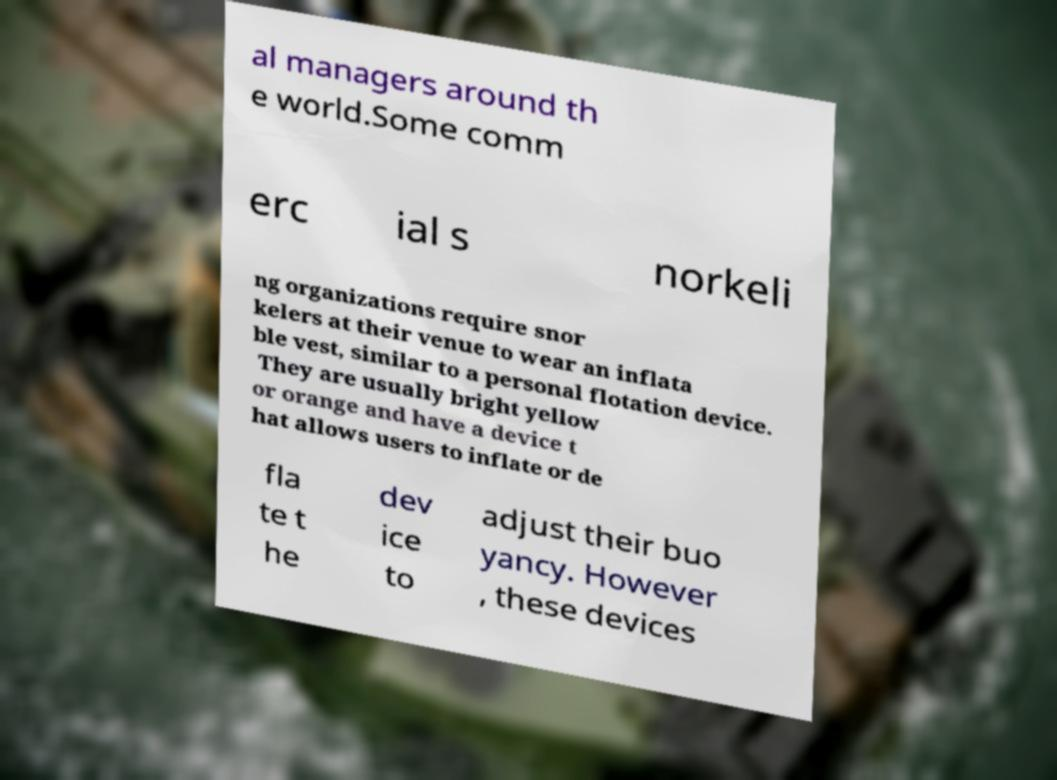Please identify and transcribe the text found in this image. al managers around th e world.Some comm erc ial s norkeli ng organizations require snor kelers at their venue to wear an inflata ble vest, similar to a personal flotation device. They are usually bright yellow or orange and have a device t hat allows users to inflate or de fla te t he dev ice to adjust their buo yancy. However , these devices 